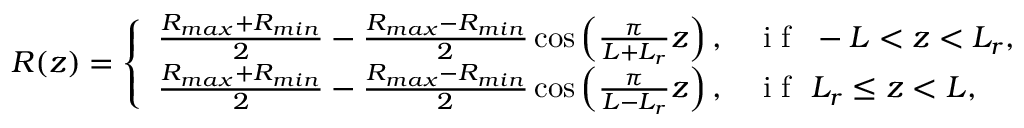<formula> <loc_0><loc_0><loc_500><loc_500>R ( z ) = \left \{ \begin{array} { l l } { \frac { R _ { \max } + R _ { \min } } { 2 } - \frac { R _ { \max } - R _ { \min } } { 2 } \cos \left ( \frac { \pi } { L + L _ { r } } z \right ) , } & { i f \ - L < z < L _ { r } , } \\ { \frac { R _ { \max } + R _ { \min } } { 2 } - \frac { R _ { \max } - R _ { \min } } { 2 } \cos \left ( \frac { \pi } { L - L _ { r } } z \right ) , } & { i f \ L _ { r } \leq z < L , } \end{array}</formula> 